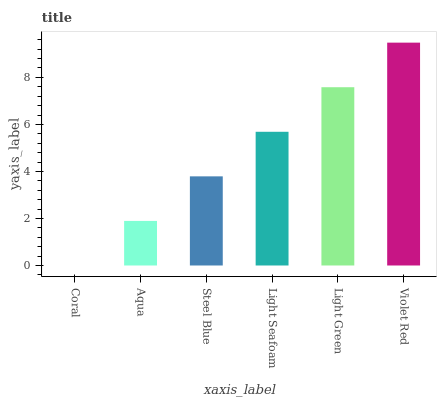Is Coral the minimum?
Answer yes or no. Yes. Is Violet Red the maximum?
Answer yes or no. Yes. Is Aqua the minimum?
Answer yes or no. No. Is Aqua the maximum?
Answer yes or no. No. Is Aqua greater than Coral?
Answer yes or no. Yes. Is Coral less than Aqua?
Answer yes or no. Yes. Is Coral greater than Aqua?
Answer yes or no. No. Is Aqua less than Coral?
Answer yes or no. No. Is Light Seafoam the high median?
Answer yes or no. Yes. Is Steel Blue the low median?
Answer yes or no. Yes. Is Violet Red the high median?
Answer yes or no. No. Is Light Green the low median?
Answer yes or no. No. 